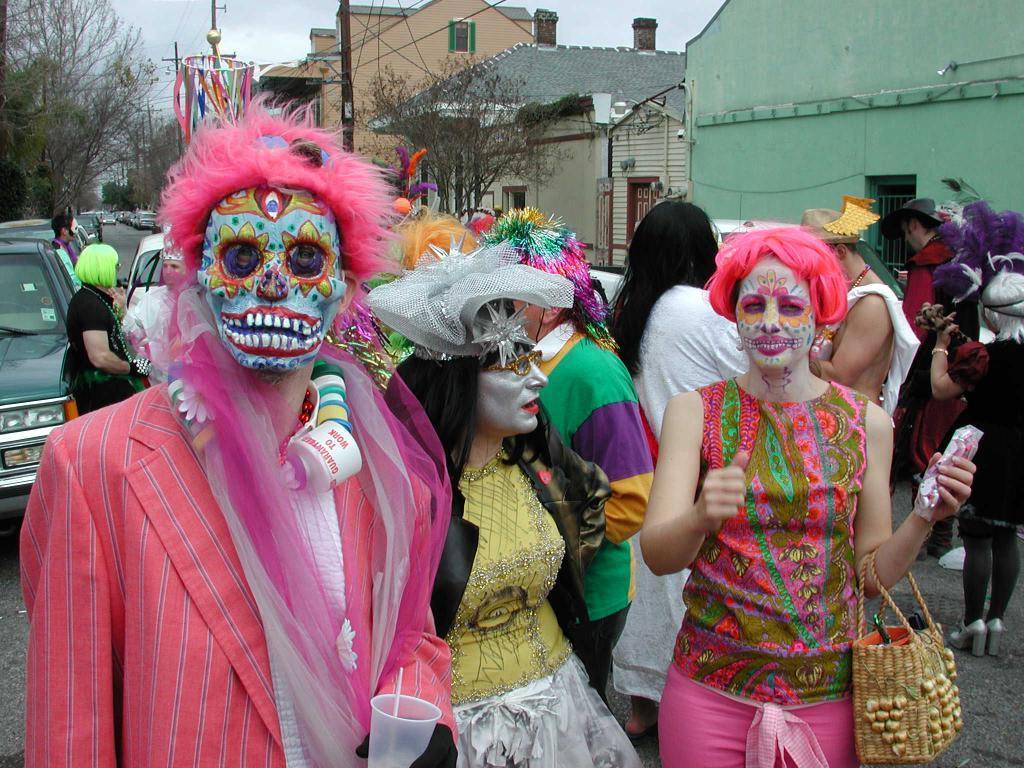Could you give a brief overview of what you see in this image? In the picture we can see three people are in different costumes and standing on the road and behind them we can also see some people are standing and talking with each other and beside them we can see some vehicles on the road and we can also see some houses and plants near it and in the background we can see some trees and sky. 